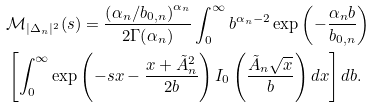Convert formula to latex. <formula><loc_0><loc_0><loc_500><loc_500>& \mathcal { M } _ { | \Delta _ { n } | ^ { 2 } } ( s ) = \frac { \left ( { \alpha _ { n } } / { b _ { 0 , n } } \right ) ^ { \alpha _ { n } } } { 2 \Gamma ( \alpha _ { n } ) } \int _ { 0 } ^ { \infty } b ^ { \alpha _ { n } - 2 } \exp \left ( - \frac { \alpha _ { n } b } { b _ { 0 , n } } \right ) \\ & \left [ \int _ { 0 } ^ { \infty } \exp \left ( - s x - \frac { x + \tilde { A } _ { n } ^ { 2 } } { 2 b } \right ) I _ { 0 } \left ( \frac { \tilde { A } _ { n } \sqrt { x } } { b } \right ) d x \right ] d b .</formula> 